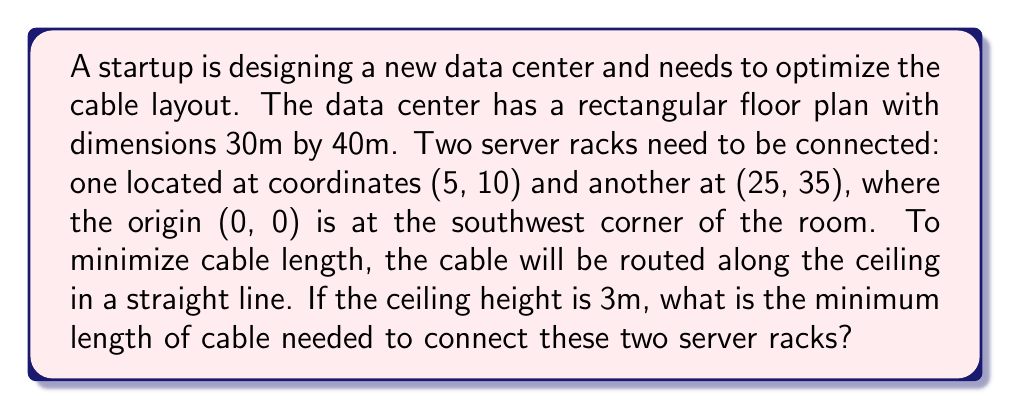Could you help me with this problem? To solve this problem, we need to use the three-dimensional distance formula, which is derived from the Pythagorean theorem. Let's approach this step-by-step:

1) First, let's identify the coordinates of the two points in 3D space:
   Point A (server rack 1): (5, 10, 3)
   Point B (server rack 2): (25, 35, 3)

2) The 3D distance formula is:
   $$d = \sqrt{(x_2-x_1)^2 + (y_2-y_1)^2 + (z_2-z_1)^2}$$

3) Let's substitute our values:
   $$d = \sqrt{(25-5)^2 + (35-10)^2 + (3-3)^2}$$

4) Simplify inside the parentheses:
   $$d = \sqrt{20^2 + 25^2 + 0^2}$$

5) Calculate the squares:
   $$d = \sqrt{400 + 625 + 0}$$

6) Sum inside the square root:
   $$d = \sqrt{1025}$$

7) Calculate the square root:
   $$d \approx 32.02 \text{ m}$$

Therefore, the minimum length of cable needed is approximately 32.02 meters.

[asy]
import geometry;

size(200);
draw((0,0)--(40,0)--(40,30)--(0,30)--cycle);
dot((5,10));
dot((25,35));
draw((5,10)--(25,35),red);
label("(5,10)",(5,10),SW);
label("(25,35)",(25,35),NE);
label("30m",(0,30),W);
label("40m",(40,0),S);
[/asy]
Answer: The minimum length of cable needed is approximately 32.02 meters. 